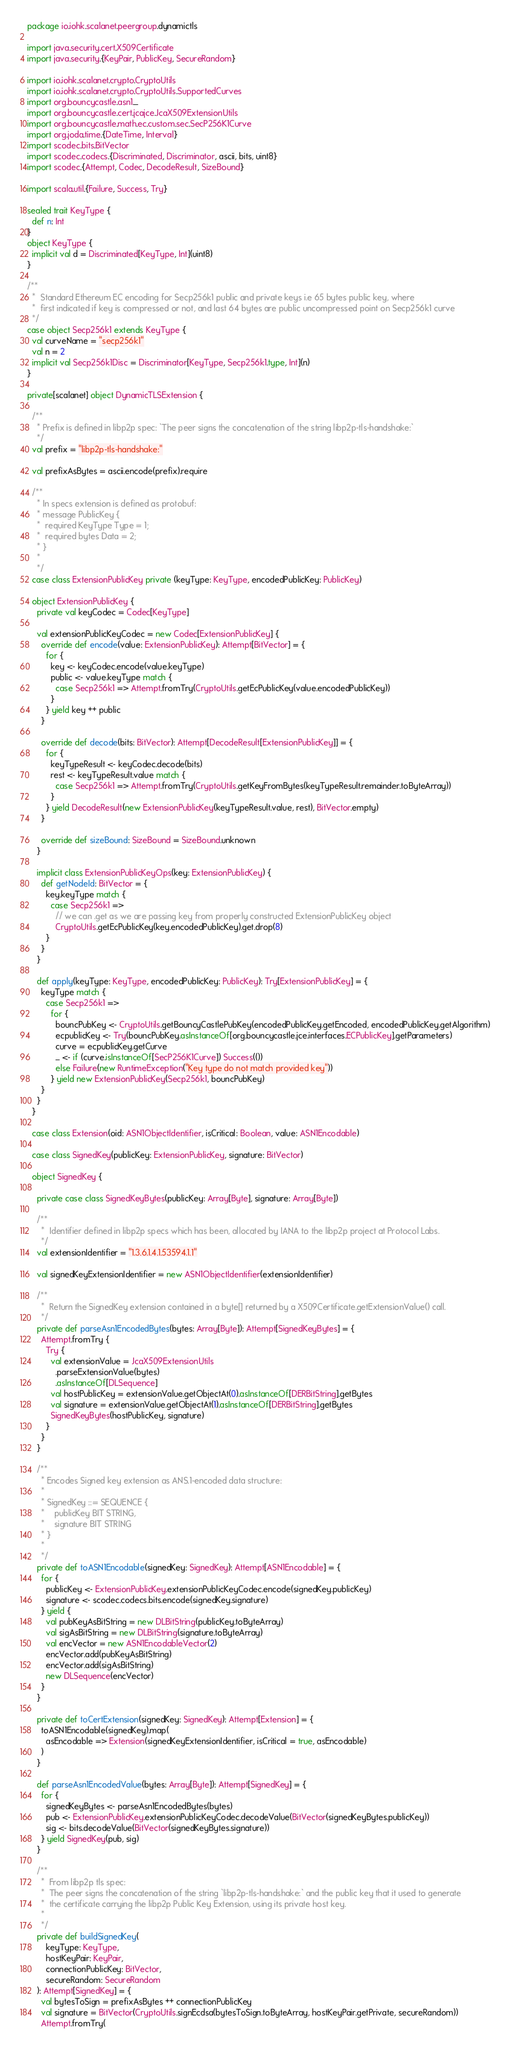<code> <loc_0><loc_0><loc_500><loc_500><_Scala_>package io.iohk.scalanet.peergroup.dynamictls

import java.security.cert.X509Certificate
import java.security.{KeyPair, PublicKey, SecureRandom}

import io.iohk.scalanet.crypto.CryptoUtils
import io.iohk.scalanet.crypto.CryptoUtils.SupportedCurves
import org.bouncycastle.asn1._
import org.bouncycastle.cert.jcajce.JcaX509ExtensionUtils
import org.bouncycastle.math.ec.custom.sec.SecP256K1Curve
import org.joda.time.{DateTime, Interval}
import scodec.bits.BitVector
import scodec.codecs.{Discriminated, Discriminator, ascii, bits, uint8}
import scodec.{Attempt, Codec, DecodeResult, SizeBound}

import scala.util.{Failure, Success, Try}

sealed trait KeyType {
  def n: Int
}
object KeyType {
  implicit val d = Discriminated[KeyType, Int](uint8)
}

/**
  *  Standard Ethereum EC encoding for Secp256k1 public and private keys i.e 65 bytes public key, where
  *  first indicated if key is compressed or not, and last 64 bytes are public uncompressed point on Secp256k1 curve
  */
case object Secp256k1 extends KeyType {
  val curveName = "secp256k1"
  val n = 2
  implicit val Secp256k1Disc = Discriminator[KeyType, Secp256k1.type, Int](n)
}

private[scalanet] object DynamicTLSExtension {

  /**
    * Prefix is defined in libp2p spec: `The peer signs the concatenation of the string libp2p-tls-handshake:`
    */
  val prefix = "libp2p-tls-handshake:"

  val prefixAsBytes = ascii.encode(prefix).require

  /**
    * In specs extension is defined as protobuf:
    * message PublicKey {
    *  required KeyType Type = 1;
    *  required bytes Data = 2;
    * }
    *
    */
  case class ExtensionPublicKey private (keyType: KeyType, encodedPublicKey: PublicKey)

  object ExtensionPublicKey {
    private val keyCodec = Codec[KeyType]

    val extensionPublicKeyCodec = new Codec[ExtensionPublicKey] {
      override def encode(value: ExtensionPublicKey): Attempt[BitVector] = {
        for {
          key <- keyCodec.encode(value.keyType)
          public <- value.keyType match {
            case Secp256k1 => Attempt.fromTry(CryptoUtils.getEcPublicKey(value.encodedPublicKey))
          }
        } yield key ++ public
      }

      override def decode(bits: BitVector): Attempt[DecodeResult[ExtensionPublicKey]] = {
        for {
          keyTypeResult <- keyCodec.decode(bits)
          rest <- keyTypeResult.value match {
            case Secp256k1 => Attempt.fromTry(CryptoUtils.getKeyFromBytes(keyTypeResult.remainder.toByteArray))
          }
        } yield DecodeResult(new ExtensionPublicKey(keyTypeResult.value, rest), BitVector.empty)
      }

      override def sizeBound: SizeBound = SizeBound.unknown
    }

    implicit class ExtensionPublicKeyOps(key: ExtensionPublicKey) {
      def getNodeId: BitVector = {
        key.keyType match {
          case Secp256k1 =>
            // we can .get as we are passing key from properly constructed ExtensionPublicKey object
            CryptoUtils.getEcPublicKey(key.encodedPublicKey).get.drop(8)
        }
      }
    }

    def apply(keyType: KeyType, encodedPublicKey: PublicKey): Try[ExtensionPublicKey] = {
      keyType match {
        case Secp256k1 =>
          for {
            bouncPubKey <- CryptoUtils.getBouncyCastlePubKey(encodedPublicKey.getEncoded, encodedPublicKey.getAlgorithm)
            ecpublicKey <- Try(bouncPubKey.asInstanceOf[org.bouncycastle.jce.interfaces.ECPublicKey].getParameters)
            curve = ecpublicKey.getCurve
            _ <- if (curve.isInstanceOf[SecP256K1Curve]) Success(())
            else Failure(new RuntimeException("Key type do not match provided key"))
          } yield new ExtensionPublicKey(Secp256k1, bouncPubKey)
      }
    }
  }

  case class Extension(oid: ASN1ObjectIdentifier, isCritical: Boolean, value: ASN1Encodable)

  case class SignedKey(publicKey: ExtensionPublicKey, signature: BitVector)

  object SignedKey {

    private case class SignedKeyBytes(publicKey: Array[Byte], signature: Array[Byte])

    /**
      *  Identifier defined in libp2p specs which has been, allocated by IANA to the libp2p project at Protocol Labs.
      */
    val extensionIdentifier = "1.3.6.1.4.1.53594.1.1"

    val signedKeyExtensionIdentifier = new ASN1ObjectIdentifier(extensionIdentifier)

    /**
      *  Return the SignedKey extension contained in a byte[] returned by a X509Certificate.getExtensionValue() call.
      */
    private def parseAsn1EncodedBytes(bytes: Array[Byte]): Attempt[SignedKeyBytes] = {
      Attempt.fromTry {
        Try {
          val extensionValue = JcaX509ExtensionUtils
            .parseExtensionValue(bytes)
            .asInstanceOf[DLSequence]
          val hostPublicKey = extensionValue.getObjectAt(0).asInstanceOf[DERBitString].getBytes
          val signature = extensionValue.getObjectAt(1).asInstanceOf[DERBitString].getBytes
          SignedKeyBytes(hostPublicKey, signature)
        }
      }
    }

    /**
      * Encodes Signed key extension as ANS.1-encoded data structure:
      *
      * SignedKey ::= SEQUENCE {
      *    publicKey BIT STRING,
      *    signature BIT STRING
      * }
      *
      */
    private def toASN1Encodable(signedKey: SignedKey): Attempt[ASN1Encodable] = {
      for {
        publicKey <- ExtensionPublicKey.extensionPublicKeyCodec.encode(signedKey.publicKey)
        signature <- scodec.codecs.bits.encode(signedKey.signature)
      } yield {
        val pubKeyAsBitString = new DLBitString(publicKey.toByteArray)
        val sigAsBitString = new DLBitString(signature.toByteArray)
        val encVector = new ASN1EncodableVector(2)
        encVector.add(pubKeyAsBitString)
        encVector.add(sigAsBitString)
        new DLSequence(encVector)
      }
    }

    private def toCertExtension(signedKey: SignedKey): Attempt[Extension] = {
      toASN1Encodable(signedKey).map(
        asEncodable => Extension(signedKeyExtensionIdentifier, isCritical = true, asEncodable)
      )
    }

    def parseAsn1EncodedValue(bytes: Array[Byte]): Attempt[SignedKey] = {
      for {
        signedKeyBytes <- parseAsn1EncodedBytes(bytes)
        pub <- ExtensionPublicKey.extensionPublicKeyCodec.decodeValue(BitVector(signedKeyBytes.publicKey))
        sig <- bits.decodeValue(BitVector(signedKeyBytes.signature))
      } yield SignedKey(pub, sig)
    }

    /**
      *  From libp2p tls spec:
      *  The peer signs the concatenation of the string `libp2p-tls-handshake:` and the public key that it used to generate
      *  the certificate carrying the libp2p Public Key Extension, using its private host key.
      *
      */
    private def buildSignedKey(
        keyType: KeyType,
        hostKeyPair: KeyPair,
        connectionPublicKey: BitVector,
        secureRandom: SecureRandom
    ): Attempt[SignedKey] = {
      val bytesToSign = prefixAsBytes ++ connectionPublicKey
      val signature = BitVector(CryptoUtils.signEcdsa(bytesToSign.toByteArray, hostKeyPair.getPrivate, secureRandom))
      Attempt.fromTry(</code> 